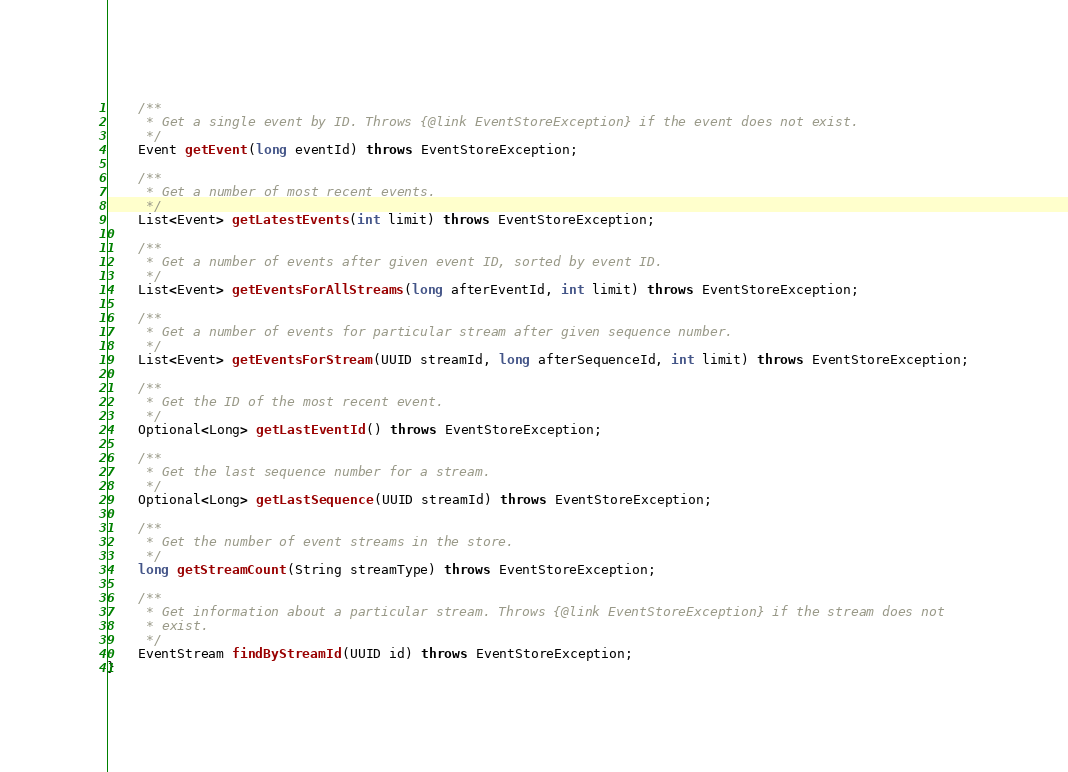<code> <loc_0><loc_0><loc_500><loc_500><_Java_>    /**
     * Get a single event by ID. Throws {@link EventStoreException} if the event does not exist.
     */
    Event getEvent(long eventId) throws EventStoreException;

    /**
     * Get a number of most recent events.
     */
    List<Event> getLatestEvents(int limit) throws EventStoreException;

    /**
     * Get a number of events after given event ID, sorted by event ID.
     */
    List<Event> getEventsForAllStreams(long afterEventId, int limit) throws EventStoreException;

    /**
     * Get a number of events for particular stream after given sequence number.
     */
    List<Event> getEventsForStream(UUID streamId, long afterSequenceId, int limit) throws EventStoreException;

    /**
     * Get the ID of the most recent event.
     */
    Optional<Long> getLastEventId() throws EventStoreException;

    /**
     * Get the last sequence number for a stream.
     */
    Optional<Long> getLastSequence(UUID streamId) throws EventStoreException;

    /**
     * Get the number of event streams in the store.
     */
    long getStreamCount(String streamType) throws EventStoreException;

    /**
     * Get information about a particular stream. Throws {@link EventStoreException} if the stream does not
     * exist.
     */
    EventStream findByStreamId(UUID id) throws EventStoreException;
}
</code> 